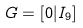<formula> <loc_0><loc_0><loc_500><loc_500>G = [ 0 | I _ { 9 } ]</formula> 